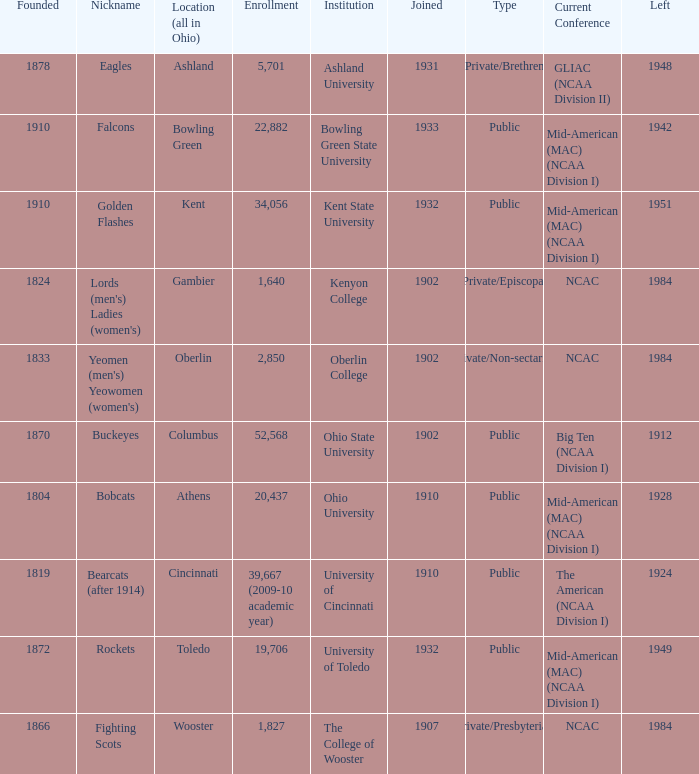What is the type of institution in Kent State University? Public. 